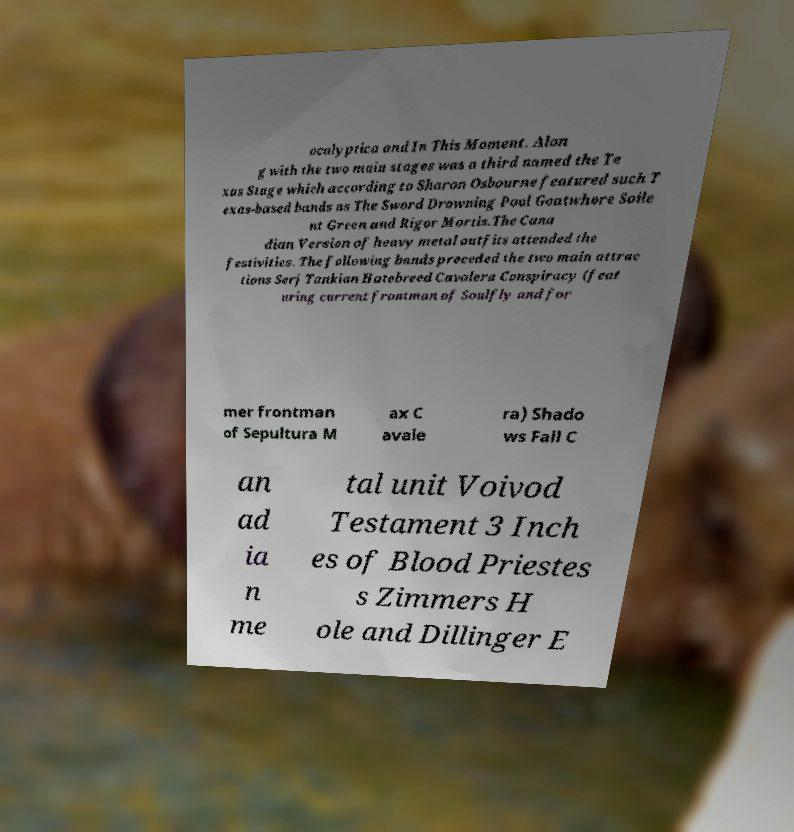Please identify and transcribe the text found in this image. ocalyptica and In This Moment. Alon g with the two main stages was a third named the Te xas Stage which according to Sharon Osbourne featured such T exas-based bands as The Sword Drowning Pool Goatwhore Soile nt Green and Rigor Mortis.The Cana dian Version of heavy metal outfits attended the festivities. The following bands preceded the two main attrac tions Serj Tankian Hatebreed Cavalera Conspiracy (feat uring current frontman of Soulfly and for mer frontman of Sepultura M ax C avale ra) Shado ws Fall C an ad ia n me tal unit Voivod Testament 3 Inch es of Blood Priestes s Zimmers H ole and Dillinger E 